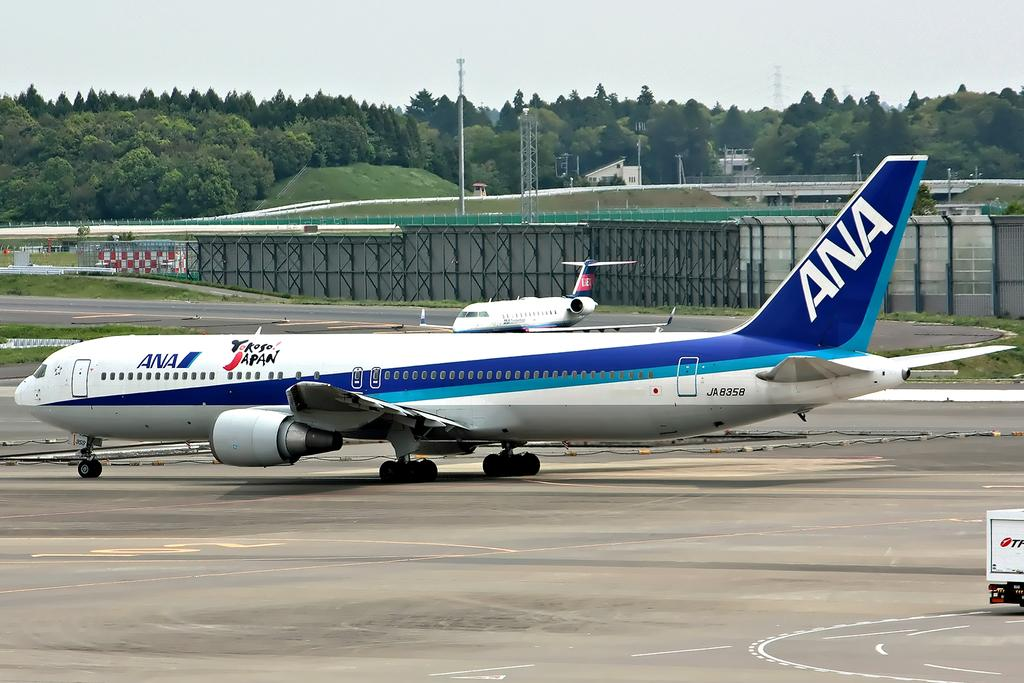What type of transportation can be seen in the image? There are aeroplanes in the image. What natural elements are present in the image? There are trees in the image. What man-made structures can be seen in the image? There are poles, towers, sheds, and grills in the image. What is the ground surface like in the image? There is a road at the bottom of the image. Is there any other vehicle or mode of transportation in the image? Yes, there is a vehicle on the right side of the image. What type of line is being drawn by the cart in the image? There is no cart present in the image, and therefore no line being drawn. What surprise can be seen in the image? There is no surprise depicted in the image; it features aeroplanes, trees, poles, towers, sheds, grills, a road, and a vehicle. 